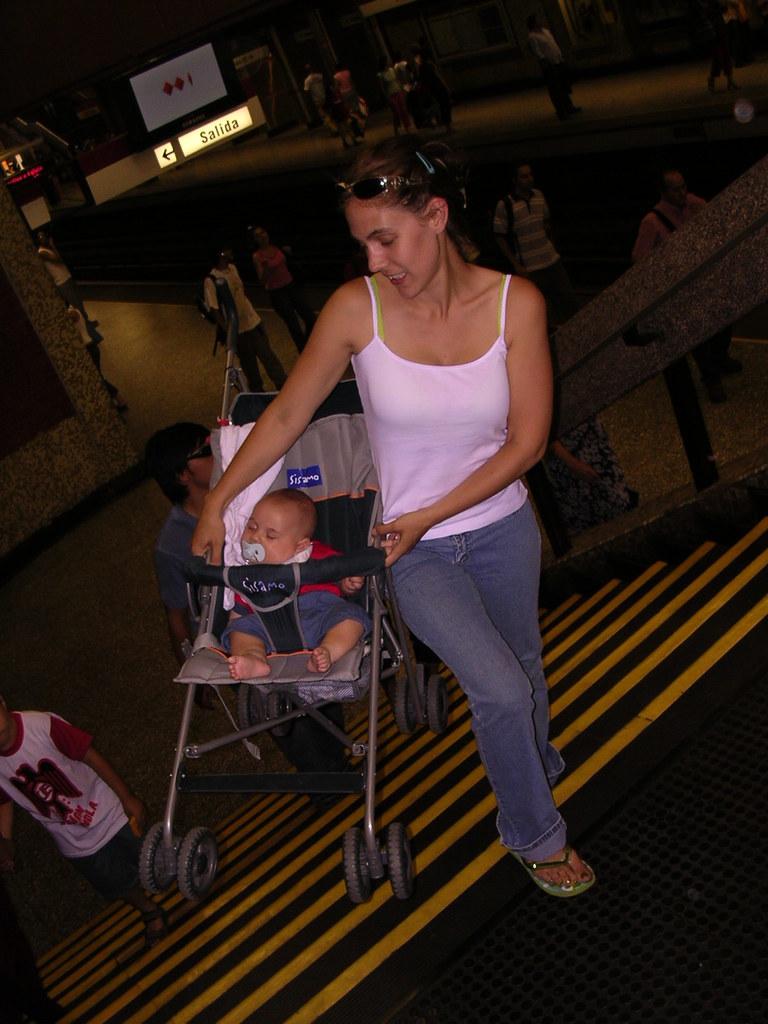How many dots are on the sign at the top of the picture?
Your response must be concise. 3. 